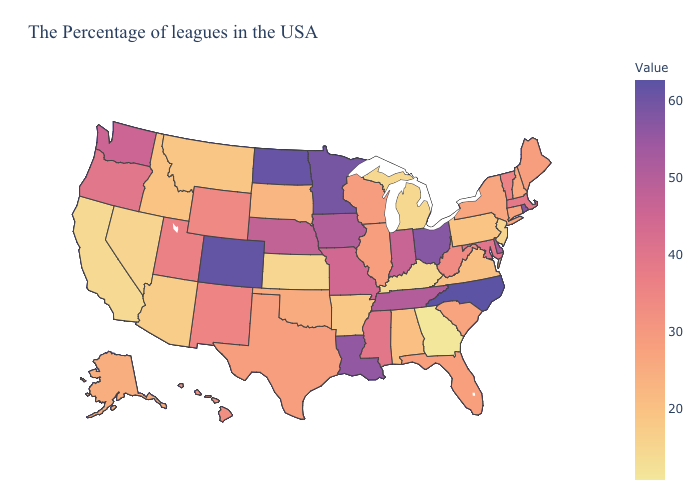Which states have the lowest value in the West?
Quick response, please. California. Does Michigan have the lowest value in the USA?
Concise answer only. No. Does Oklahoma have a lower value than Georgia?
Quick response, please. No. Does North Carolina have the highest value in the South?
Concise answer only. Yes. Which states have the lowest value in the West?
Keep it brief. California. 